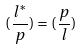<formula> <loc_0><loc_0><loc_500><loc_500>( \frac { l ^ { * } } { p } ) = ( \frac { p } { l } )</formula> 